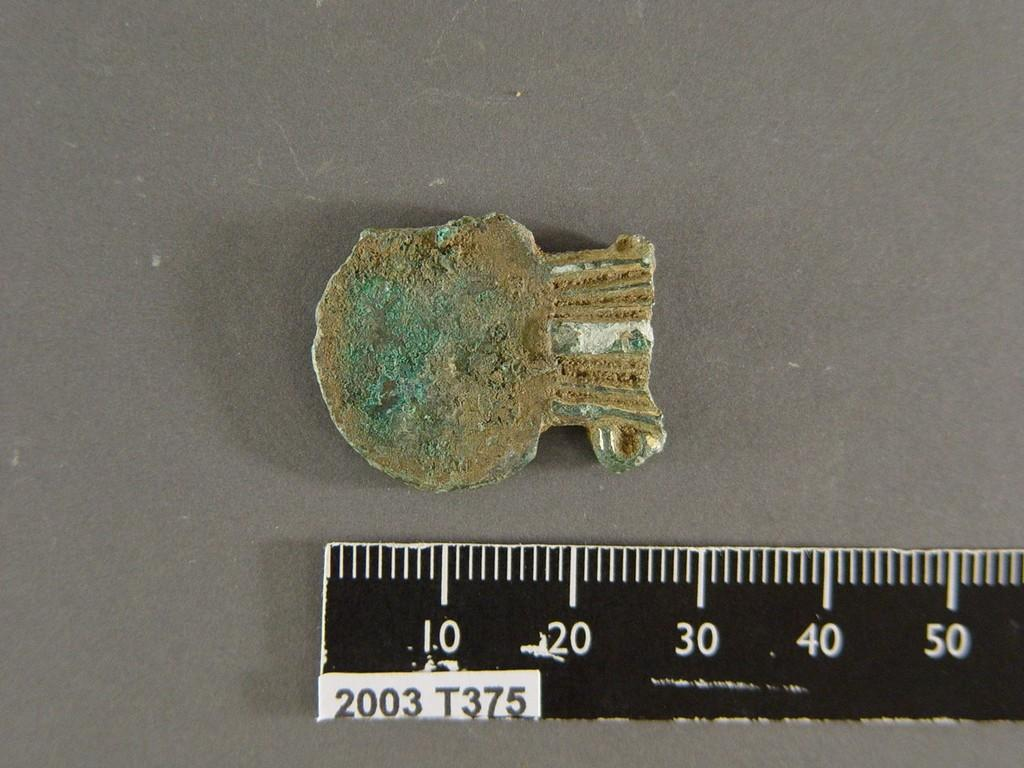Provide a one-sentence caption for the provided image. A ruler has a small sticker on it which contains the date 2003. 